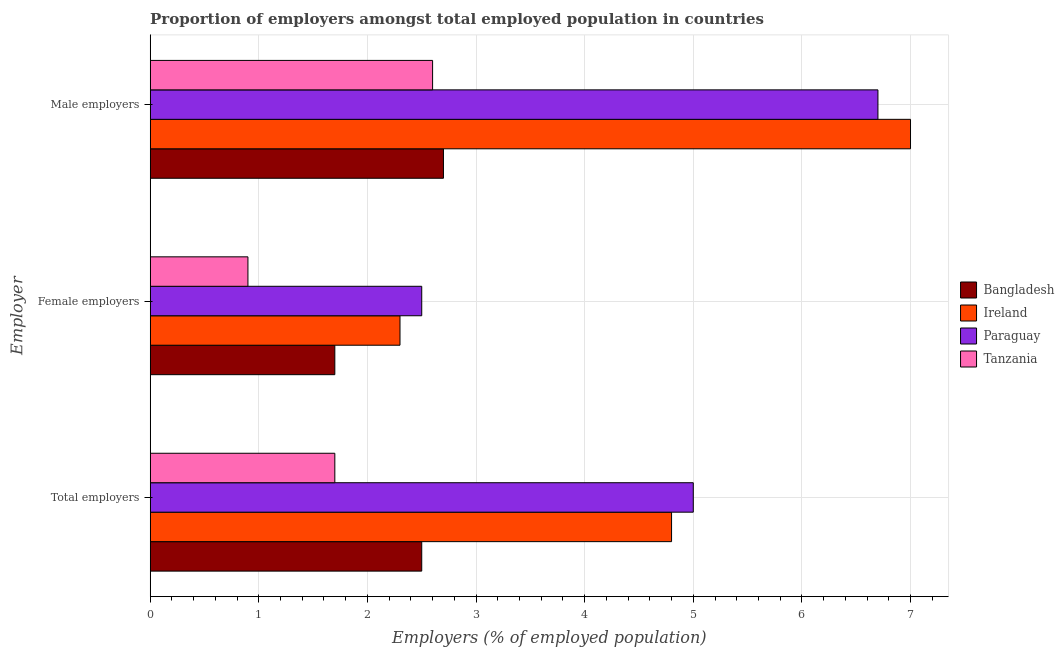How many groups of bars are there?
Your answer should be compact. 3. Are the number of bars per tick equal to the number of legend labels?
Provide a succinct answer. Yes. Are the number of bars on each tick of the Y-axis equal?
Your answer should be very brief. Yes. How many bars are there on the 2nd tick from the top?
Provide a succinct answer. 4. What is the label of the 1st group of bars from the top?
Your answer should be very brief. Male employers. What is the percentage of male employers in Tanzania?
Your response must be concise. 2.6. Across all countries, what is the maximum percentage of total employers?
Give a very brief answer. 5. Across all countries, what is the minimum percentage of female employers?
Offer a very short reply. 0.9. In which country was the percentage of total employers maximum?
Provide a short and direct response. Paraguay. In which country was the percentage of female employers minimum?
Your answer should be very brief. Tanzania. What is the total percentage of female employers in the graph?
Give a very brief answer. 7.4. What is the difference between the percentage of total employers in Ireland and that in Tanzania?
Give a very brief answer. 3.1. What is the average percentage of male employers per country?
Your answer should be compact. 4.75. What is the difference between the percentage of male employers and percentage of total employers in Tanzania?
Keep it short and to the point. 0.9. In how many countries, is the percentage of male employers greater than 0.8 %?
Your answer should be very brief. 4. What is the ratio of the percentage of female employers in Paraguay to that in Tanzania?
Your answer should be compact. 2.78. What is the difference between the highest and the second highest percentage of female employers?
Your answer should be very brief. 0.2. What is the difference between the highest and the lowest percentage of female employers?
Ensure brevity in your answer.  1.6. Is the sum of the percentage of male employers in Paraguay and Ireland greater than the maximum percentage of total employers across all countries?
Give a very brief answer. Yes. What does the 2nd bar from the top in Total employers represents?
Offer a terse response. Paraguay. Is it the case that in every country, the sum of the percentage of total employers and percentage of female employers is greater than the percentage of male employers?
Offer a terse response. Yes. How many bars are there?
Ensure brevity in your answer.  12. How many countries are there in the graph?
Provide a short and direct response. 4. What is the difference between two consecutive major ticks on the X-axis?
Your answer should be compact. 1. Does the graph contain any zero values?
Your answer should be very brief. No. Does the graph contain grids?
Provide a succinct answer. Yes. Where does the legend appear in the graph?
Keep it short and to the point. Center right. How are the legend labels stacked?
Your answer should be compact. Vertical. What is the title of the graph?
Provide a succinct answer. Proportion of employers amongst total employed population in countries. What is the label or title of the X-axis?
Your response must be concise. Employers (% of employed population). What is the label or title of the Y-axis?
Provide a short and direct response. Employer. What is the Employers (% of employed population) of Ireland in Total employers?
Provide a succinct answer. 4.8. What is the Employers (% of employed population) in Paraguay in Total employers?
Offer a terse response. 5. What is the Employers (% of employed population) of Tanzania in Total employers?
Offer a very short reply. 1.7. What is the Employers (% of employed population) in Bangladesh in Female employers?
Give a very brief answer. 1.7. What is the Employers (% of employed population) in Ireland in Female employers?
Offer a terse response. 2.3. What is the Employers (% of employed population) in Paraguay in Female employers?
Offer a very short reply. 2.5. What is the Employers (% of employed population) of Tanzania in Female employers?
Offer a terse response. 0.9. What is the Employers (% of employed population) in Bangladesh in Male employers?
Your response must be concise. 2.7. What is the Employers (% of employed population) in Paraguay in Male employers?
Provide a succinct answer. 6.7. What is the Employers (% of employed population) of Tanzania in Male employers?
Provide a short and direct response. 2.6. Across all Employer, what is the maximum Employers (% of employed population) in Bangladesh?
Provide a succinct answer. 2.7. Across all Employer, what is the maximum Employers (% of employed population) of Paraguay?
Ensure brevity in your answer.  6.7. Across all Employer, what is the maximum Employers (% of employed population) in Tanzania?
Make the answer very short. 2.6. Across all Employer, what is the minimum Employers (% of employed population) in Bangladesh?
Your answer should be very brief. 1.7. Across all Employer, what is the minimum Employers (% of employed population) in Ireland?
Your answer should be very brief. 2.3. Across all Employer, what is the minimum Employers (% of employed population) in Tanzania?
Ensure brevity in your answer.  0.9. What is the total Employers (% of employed population) of Ireland in the graph?
Your answer should be compact. 14.1. What is the total Employers (% of employed population) in Tanzania in the graph?
Give a very brief answer. 5.2. What is the difference between the Employers (% of employed population) in Ireland in Total employers and that in Female employers?
Give a very brief answer. 2.5. What is the difference between the Employers (% of employed population) of Paraguay in Total employers and that in Female employers?
Your answer should be very brief. 2.5. What is the difference between the Employers (% of employed population) in Tanzania in Total employers and that in Female employers?
Offer a terse response. 0.8. What is the difference between the Employers (% of employed population) in Ireland in Total employers and that in Male employers?
Ensure brevity in your answer.  -2.2. What is the difference between the Employers (% of employed population) of Tanzania in Total employers and that in Male employers?
Make the answer very short. -0.9. What is the difference between the Employers (% of employed population) in Paraguay in Female employers and that in Male employers?
Provide a short and direct response. -4.2. What is the difference between the Employers (% of employed population) in Tanzania in Female employers and that in Male employers?
Your response must be concise. -1.7. What is the difference between the Employers (% of employed population) of Bangladesh in Total employers and the Employers (% of employed population) of Paraguay in Female employers?
Your answer should be very brief. 0. What is the difference between the Employers (% of employed population) in Bangladesh in Total employers and the Employers (% of employed population) in Tanzania in Female employers?
Your answer should be very brief. 1.6. What is the difference between the Employers (% of employed population) of Ireland in Total employers and the Employers (% of employed population) of Paraguay in Female employers?
Provide a succinct answer. 2.3. What is the difference between the Employers (% of employed population) in Bangladesh in Total employers and the Employers (% of employed population) in Ireland in Male employers?
Keep it short and to the point. -4.5. What is the difference between the Employers (% of employed population) of Bangladesh in Total employers and the Employers (% of employed population) of Paraguay in Male employers?
Your answer should be compact. -4.2. What is the difference between the Employers (% of employed population) of Ireland in Total employers and the Employers (% of employed population) of Paraguay in Male employers?
Give a very brief answer. -1.9. What is the difference between the Employers (% of employed population) of Paraguay in Total employers and the Employers (% of employed population) of Tanzania in Male employers?
Ensure brevity in your answer.  2.4. What is the difference between the Employers (% of employed population) of Bangladesh in Female employers and the Employers (% of employed population) of Ireland in Male employers?
Offer a terse response. -5.3. What is the difference between the Employers (% of employed population) in Ireland in Female employers and the Employers (% of employed population) in Paraguay in Male employers?
Offer a very short reply. -4.4. What is the difference between the Employers (% of employed population) of Paraguay in Female employers and the Employers (% of employed population) of Tanzania in Male employers?
Offer a very short reply. -0.1. What is the average Employers (% of employed population) in Ireland per Employer?
Your response must be concise. 4.7. What is the average Employers (% of employed population) of Paraguay per Employer?
Offer a very short reply. 4.73. What is the average Employers (% of employed population) in Tanzania per Employer?
Provide a succinct answer. 1.73. What is the difference between the Employers (% of employed population) in Ireland and Employers (% of employed population) in Paraguay in Total employers?
Provide a succinct answer. -0.2. What is the difference between the Employers (% of employed population) of Ireland and Employers (% of employed population) of Tanzania in Total employers?
Provide a succinct answer. 3.1. What is the difference between the Employers (% of employed population) of Bangladesh and Employers (% of employed population) of Paraguay in Female employers?
Your answer should be compact. -0.8. What is the difference between the Employers (% of employed population) of Bangladesh and Employers (% of employed population) of Tanzania in Female employers?
Keep it short and to the point. 0.8. What is the difference between the Employers (% of employed population) of Bangladesh and Employers (% of employed population) of Tanzania in Male employers?
Make the answer very short. 0.1. What is the difference between the Employers (% of employed population) in Paraguay and Employers (% of employed population) in Tanzania in Male employers?
Make the answer very short. 4.1. What is the ratio of the Employers (% of employed population) in Bangladesh in Total employers to that in Female employers?
Give a very brief answer. 1.47. What is the ratio of the Employers (% of employed population) of Ireland in Total employers to that in Female employers?
Your response must be concise. 2.09. What is the ratio of the Employers (% of employed population) in Paraguay in Total employers to that in Female employers?
Keep it short and to the point. 2. What is the ratio of the Employers (% of employed population) in Tanzania in Total employers to that in Female employers?
Give a very brief answer. 1.89. What is the ratio of the Employers (% of employed population) in Bangladesh in Total employers to that in Male employers?
Your answer should be very brief. 0.93. What is the ratio of the Employers (% of employed population) of Ireland in Total employers to that in Male employers?
Ensure brevity in your answer.  0.69. What is the ratio of the Employers (% of employed population) in Paraguay in Total employers to that in Male employers?
Your answer should be very brief. 0.75. What is the ratio of the Employers (% of employed population) in Tanzania in Total employers to that in Male employers?
Your answer should be compact. 0.65. What is the ratio of the Employers (% of employed population) of Bangladesh in Female employers to that in Male employers?
Provide a short and direct response. 0.63. What is the ratio of the Employers (% of employed population) in Ireland in Female employers to that in Male employers?
Make the answer very short. 0.33. What is the ratio of the Employers (% of employed population) of Paraguay in Female employers to that in Male employers?
Give a very brief answer. 0.37. What is the ratio of the Employers (% of employed population) of Tanzania in Female employers to that in Male employers?
Keep it short and to the point. 0.35. What is the difference between the highest and the second highest Employers (% of employed population) of Ireland?
Your answer should be compact. 2.2. What is the difference between the highest and the lowest Employers (% of employed population) of Bangladesh?
Offer a very short reply. 1. What is the difference between the highest and the lowest Employers (% of employed population) in Ireland?
Offer a very short reply. 4.7. 